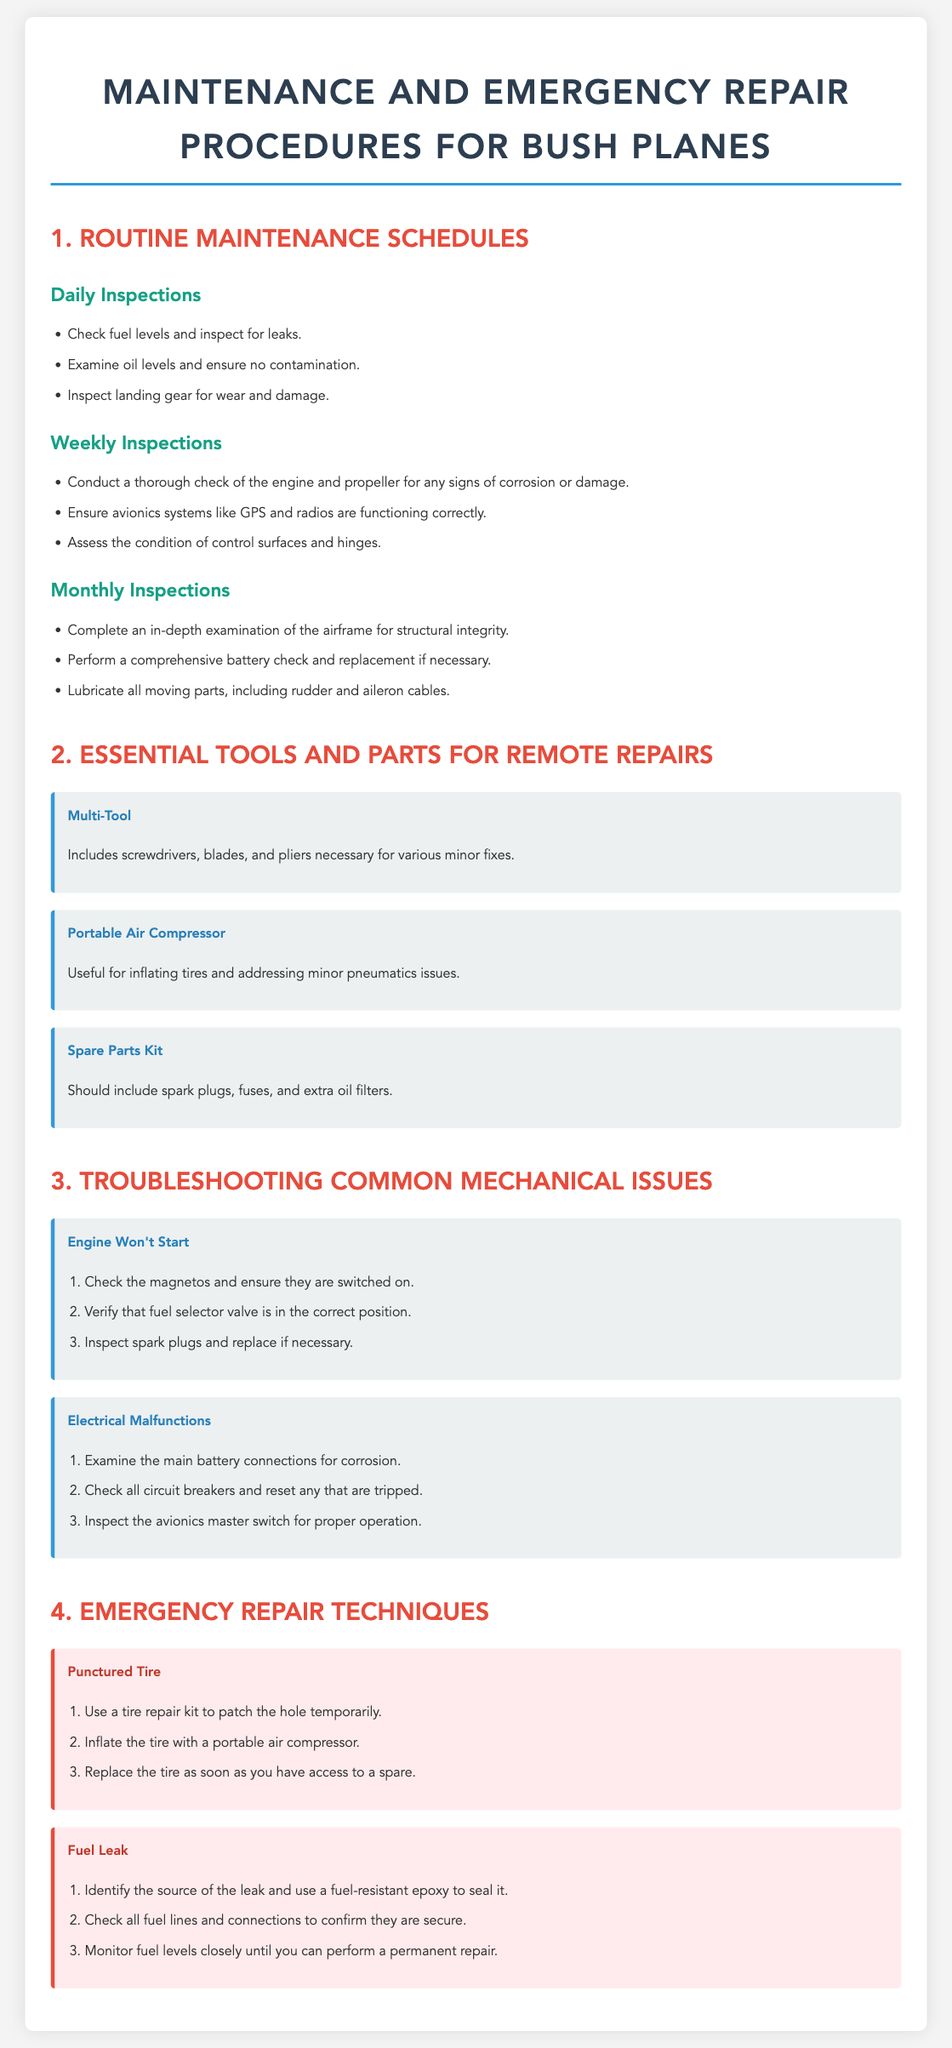What should you check during daily inspections? Daily inspections require checking fuel levels, oil levels, and landing gear condition.
Answer: Fuel levels, oil levels, landing gear How often should you perform thorough checks of the engine and propeller? Thorough checks of the engine and propeller should be conducted weekly as per the maintenance schedule.
Answer: Weekly What items should be included in the spare parts kit? The spare parts kit should include spark plugs, fuses, and extra oil filters.
Answer: Spark plugs, fuses, extra oil filters What is the first step in troubleshooting an engine that won’t start? The first step in troubleshooting is to check the magnetos and ensure they are switched on.
Answer: Check the magnetos What should you do if you find a fuel leak? If you find a fuel leak, identify the source and use a fuel-resistant epoxy to seal it temporarily.
Answer: Use a fuel-resistant epoxy How frequently should an in-depth examination of the airframe be completed? An in-depth examination of the airframe should be completed monthly.
Answer: Monthly What is essential for patching a punctured tire temporarily? A tire repair kit is essential for patching a punctured tire temporarily.
Answer: Tire repair kit Which systems should be checked during weekly inspections for proper functionality? During weekly inspections, avionics systems like GPS and radios should be checked for functionality.
Answer: GPS, radios How often should you lubricate all moving parts? Lubrication of all moving parts should be performed during monthly inspections.
Answer: Monthly 